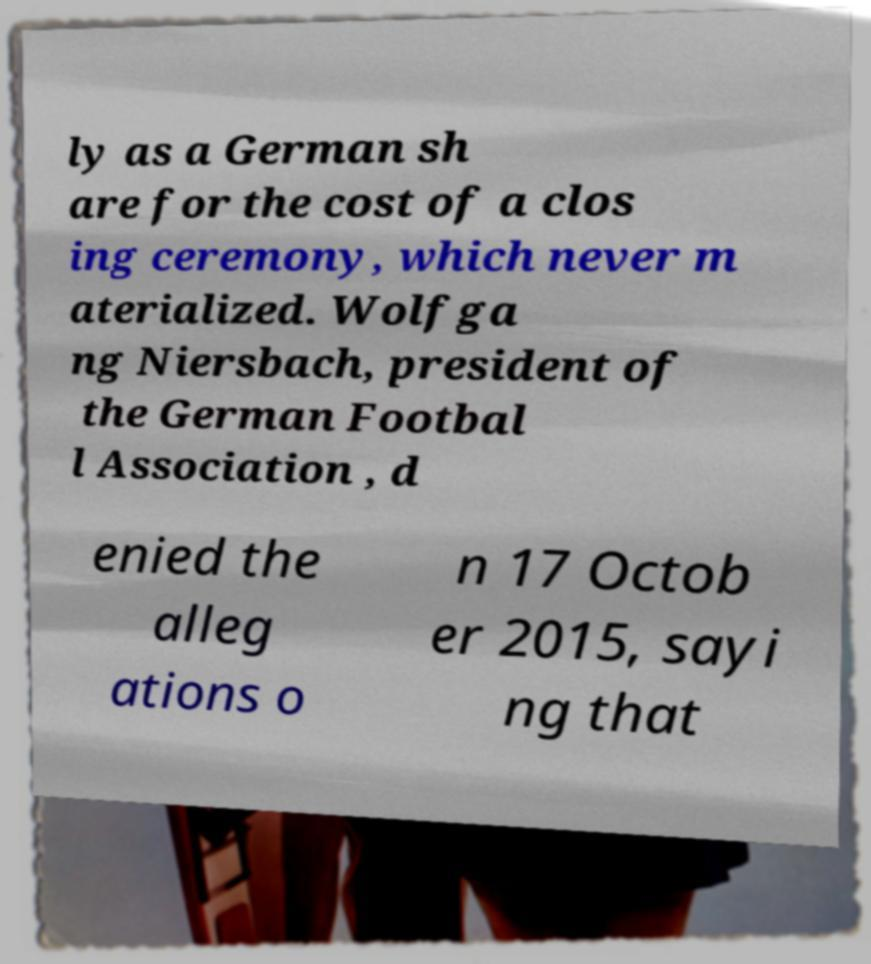What messages or text are displayed in this image? I need them in a readable, typed format. ly as a German sh are for the cost of a clos ing ceremony, which never m aterialized. Wolfga ng Niersbach, president of the German Footbal l Association , d enied the alleg ations o n 17 Octob er 2015, sayi ng that 